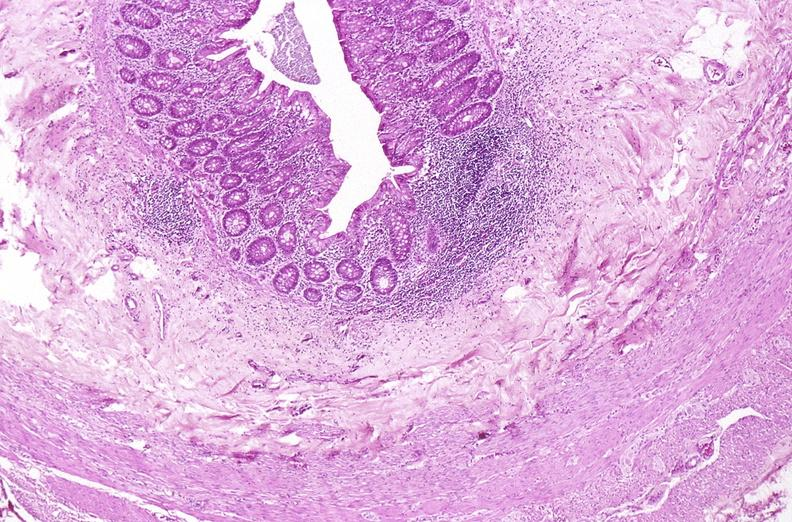s foot present?
Answer the question using a single word or phrase. No 